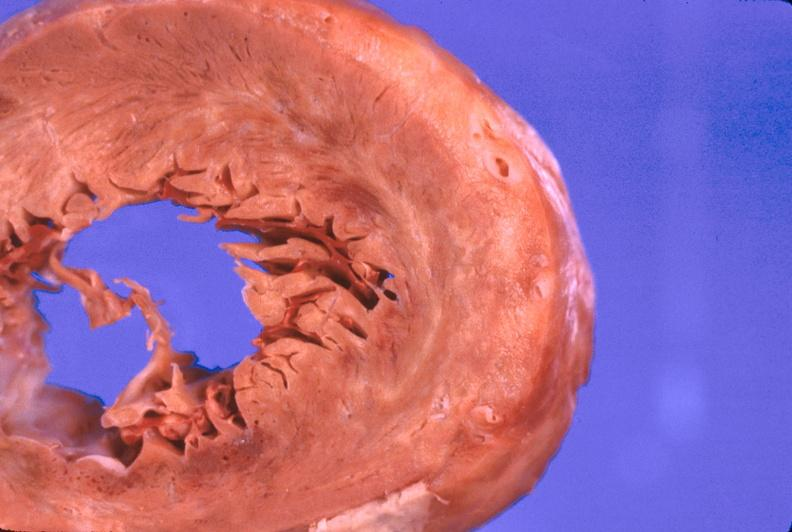what is present?
Answer the question using a single word or phrase. Cardiovascular 